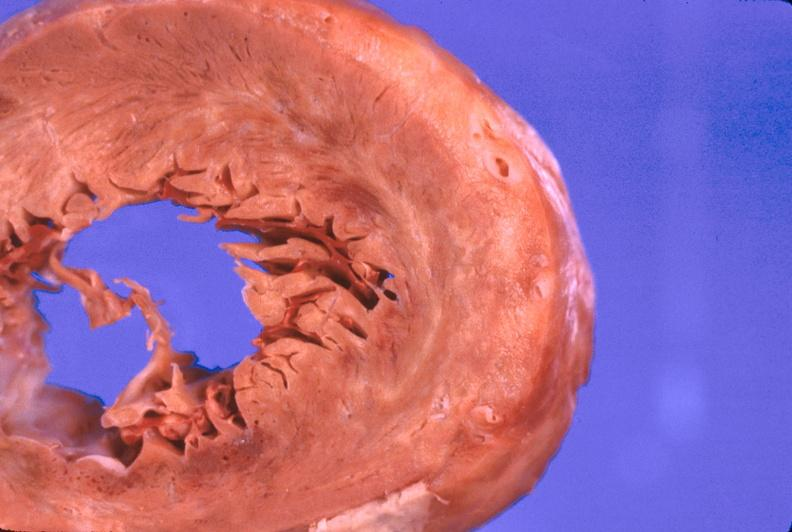what is present?
Answer the question using a single word or phrase. Cardiovascular 